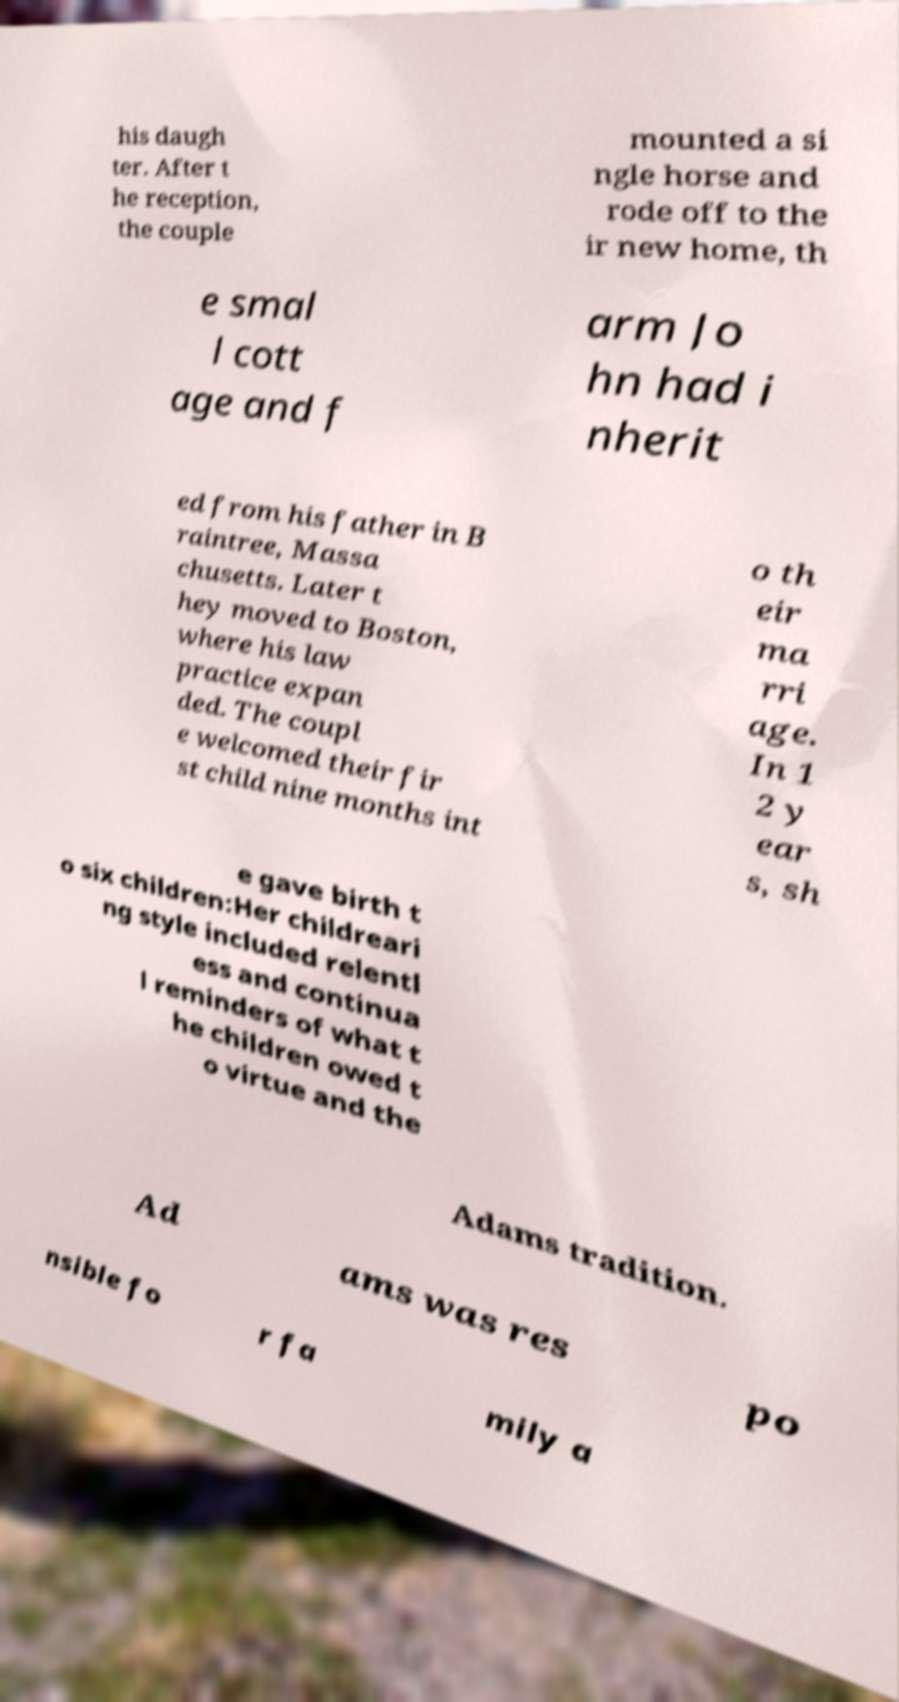Please identify and transcribe the text found in this image. his daugh ter. After t he reception, the couple mounted a si ngle horse and rode off to the ir new home, th e smal l cott age and f arm Jo hn had i nherit ed from his father in B raintree, Massa chusetts. Later t hey moved to Boston, where his law practice expan ded. The coupl e welcomed their fir st child nine months int o th eir ma rri age. In 1 2 y ear s, sh e gave birth t o six children:Her childreari ng style included relentl ess and continua l reminders of what t he children owed t o virtue and the Adams tradition. Ad ams was res po nsible fo r fa mily a 